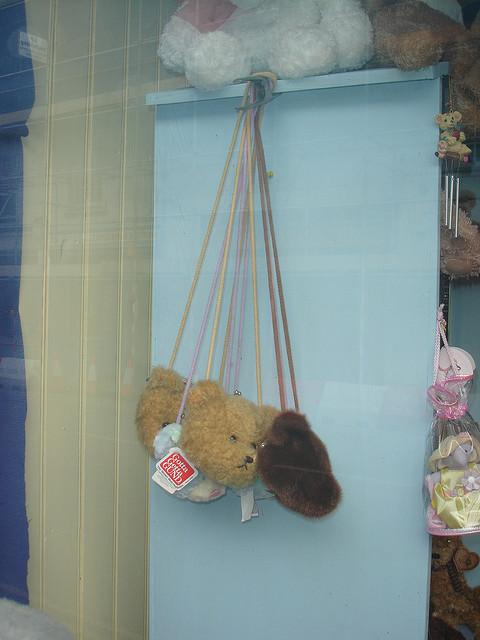What is the bear here doing? hanging 